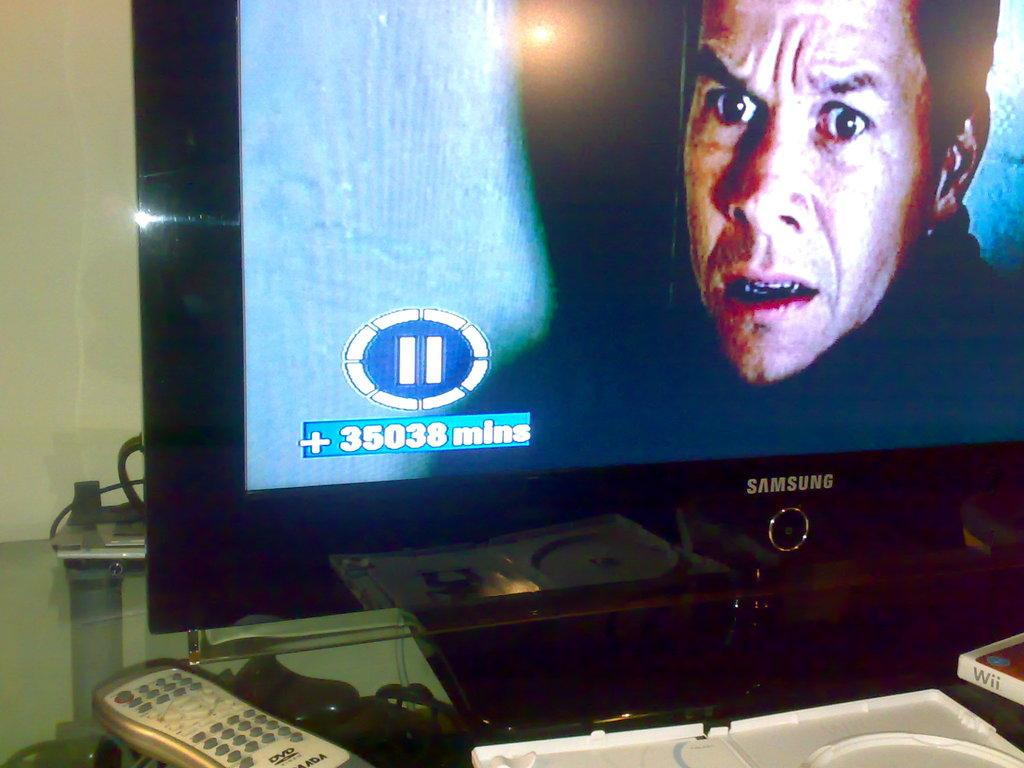Provide a one-sentence caption for the provided image. a plus sign that is on the Samsung television. 